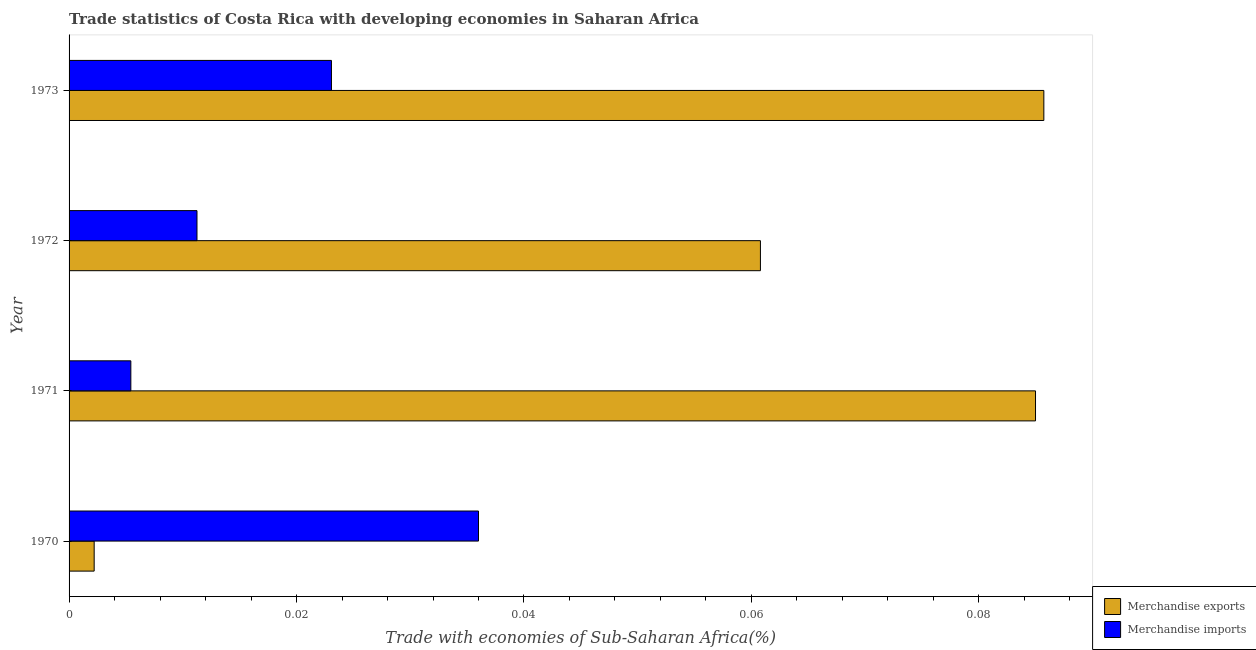How many different coloured bars are there?
Ensure brevity in your answer.  2. How many groups of bars are there?
Keep it short and to the point. 4. How many bars are there on the 2nd tick from the top?
Provide a succinct answer. 2. How many bars are there on the 3rd tick from the bottom?
Offer a terse response. 2. What is the merchandise imports in 1973?
Offer a very short reply. 0.02. Across all years, what is the maximum merchandise exports?
Your answer should be very brief. 0.09. Across all years, what is the minimum merchandise exports?
Offer a terse response. 0. In which year was the merchandise exports maximum?
Offer a terse response. 1973. What is the total merchandise imports in the graph?
Offer a very short reply. 0.08. What is the difference between the merchandise exports in 1970 and that in 1971?
Provide a succinct answer. -0.08. What is the difference between the merchandise imports in 1971 and the merchandise exports in 1972?
Offer a very short reply. -0.06. What is the average merchandise exports per year?
Provide a short and direct response. 0.06. In the year 1973, what is the difference between the merchandise imports and merchandise exports?
Offer a terse response. -0.06. In how many years, is the merchandise imports greater than 0.048 %?
Provide a succinct answer. 0. What is the ratio of the merchandise exports in 1970 to that in 1973?
Provide a short and direct response. 0.03. What is the difference between the highest and the second highest merchandise exports?
Your response must be concise. 0. What is the difference between the highest and the lowest merchandise exports?
Offer a terse response. 0.08. In how many years, is the merchandise exports greater than the average merchandise exports taken over all years?
Keep it short and to the point. 3. Is the sum of the merchandise imports in 1970 and 1972 greater than the maximum merchandise exports across all years?
Offer a very short reply. No. What does the 1st bar from the top in 1971 represents?
Provide a succinct answer. Merchandise imports. What does the 2nd bar from the bottom in 1973 represents?
Keep it short and to the point. Merchandise imports. How many years are there in the graph?
Offer a terse response. 4. What is the difference between two consecutive major ticks on the X-axis?
Your answer should be compact. 0.02. Are the values on the major ticks of X-axis written in scientific E-notation?
Your answer should be compact. No. Does the graph contain any zero values?
Make the answer very short. No. Does the graph contain grids?
Give a very brief answer. No. How are the legend labels stacked?
Provide a short and direct response. Vertical. What is the title of the graph?
Offer a very short reply. Trade statistics of Costa Rica with developing economies in Saharan Africa. Does "% of GNI" appear as one of the legend labels in the graph?
Your answer should be compact. No. What is the label or title of the X-axis?
Your answer should be very brief. Trade with economies of Sub-Saharan Africa(%). What is the Trade with economies of Sub-Saharan Africa(%) in Merchandise exports in 1970?
Your answer should be very brief. 0. What is the Trade with economies of Sub-Saharan Africa(%) in Merchandise imports in 1970?
Your answer should be compact. 0.04. What is the Trade with economies of Sub-Saharan Africa(%) of Merchandise exports in 1971?
Provide a short and direct response. 0.08. What is the Trade with economies of Sub-Saharan Africa(%) in Merchandise imports in 1971?
Offer a terse response. 0.01. What is the Trade with economies of Sub-Saharan Africa(%) in Merchandise exports in 1972?
Make the answer very short. 0.06. What is the Trade with economies of Sub-Saharan Africa(%) in Merchandise imports in 1972?
Give a very brief answer. 0.01. What is the Trade with economies of Sub-Saharan Africa(%) in Merchandise exports in 1973?
Keep it short and to the point. 0.09. What is the Trade with economies of Sub-Saharan Africa(%) of Merchandise imports in 1973?
Make the answer very short. 0.02. Across all years, what is the maximum Trade with economies of Sub-Saharan Africa(%) in Merchandise exports?
Keep it short and to the point. 0.09. Across all years, what is the maximum Trade with economies of Sub-Saharan Africa(%) in Merchandise imports?
Your answer should be compact. 0.04. Across all years, what is the minimum Trade with economies of Sub-Saharan Africa(%) in Merchandise exports?
Keep it short and to the point. 0. Across all years, what is the minimum Trade with economies of Sub-Saharan Africa(%) in Merchandise imports?
Your answer should be compact. 0.01. What is the total Trade with economies of Sub-Saharan Africa(%) in Merchandise exports in the graph?
Keep it short and to the point. 0.23. What is the total Trade with economies of Sub-Saharan Africa(%) in Merchandise imports in the graph?
Offer a terse response. 0.08. What is the difference between the Trade with economies of Sub-Saharan Africa(%) of Merchandise exports in 1970 and that in 1971?
Your response must be concise. -0.08. What is the difference between the Trade with economies of Sub-Saharan Africa(%) in Merchandise imports in 1970 and that in 1971?
Give a very brief answer. 0.03. What is the difference between the Trade with economies of Sub-Saharan Africa(%) in Merchandise exports in 1970 and that in 1972?
Offer a very short reply. -0.06. What is the difference between the Trade with economies of Sub-Saharan Africa(%) of Merchandise imports in 1970 and that in 1972?
Ensure brevity in your answer.  0.02. What is the difference between the Trade with economies of Sub-Saharan Africa(%) in Merchandise exports in 1970 and that in 1973?
Provide a short and direct response. -0.08. What is the difference between the Trade with economies of Sub-Saharan Africa(%) of Merchandise imports in 1970 and that in 1973?
Provide a short and direct response. 0.01. What is the difference between the Trade with economies of Sub-Saharan Africa(%) in Merchandise exports in 1971 and that in 1972?
Give a very brief answer. 0.02. What is the difference between the Trade with economies of Sub-Saharan Africa(%) in Merchandise imports in 1971 and that in 1972?
Give a very brief answer. -0.01. What is the difference between the Trade with economies of Sub-Saharan Africa(%) in Merchandise exports in 1971 and that in 1973?
Offer a terse response. -0. What is the difference between the Trade with economies of Sub-Saharan Africa(%) of Merchandise imports in 1971 and that in 1973?
Provide a short and direct response. -0.02. What is the difference between the Trade with economies of Sub-Saharan Africa(%) in Merchandise exports in 1972 and that in 1973?
Offer a terse response. -0.02. What is the difference between the Trade with economies of Sub-Saharan Africa(%) of Merchandise imports in 1972 and that in 1973?
Your answer should be compact. -0.01. What is the difference between the Trade with economies of Sub-Saharan Africa(%) in Merchandise exports in 1970 and the Trade with economies of Sub-Saharan Africa(%) in Merchandise imports in 1971?
Offer a very short reply. -0. What is the difference between the Trade with economies of Sub-Saharan Africa(%) in Merchandise exports in 1970 and the Trade with economies of Sub-Saharan Africa(%) in Merchandise imports in 1972?
Provide a short and direct response. -0.01. What is the difference between the Trade with economies of Sub-Saharan Africa(%) of Merchandise exports in 1970 and the Trade with economies of Sub-Saharan Africa(%) of Merchandise imports in 1973?
Provide a short and direct response. -0.02. What is the difference between the Trade with economies of Sub-Saharan Africa(%) of Merchandise exports in 1971 and the Trade with economies of Sub-Saharan Africa(%) of Merchandise imports in 1972?
Offer a terse response. 0.07. What is the difference between the Trade with economies of Sub-Saharan Africa(%) in Merchandise exports in 1971 and the Trade with economies of Sub-Saharan Africa(%) in Merchandise imports in 1973?
Give a very brief answer. 0.06. What is the difference between the Trade with economies of Sub-Saharan Africa(%) in Merchandise exports in 1972 and the Trade with economies of Sub-Saharan Africa(%) in Merchandise imports in 1973?
Offer a very short reply. 0.04. What is the average Trade with economies of Sub-Saharan Africa(%) in Merchandise exports per year?
Your response must be concise. 0.06. What is the average Trade with economies of Sub-Saharan Africa(%) in Merchandise imports per year?
Make the answer very short. 0.02. In the year 1970, what is the difference between the Trade with economies of Sub-Saharan Africa(%) of Merchandise exports and Trade with economies of Sub-Saharan Africa(%) of Merchandise imports?
Make the answer very short. -0.03. In the year 1971, what is the difference between the Trade with economies of Sub-Saharan Africa(%) of Merchandise exports and Trade with economies of Sub-Saharan Africa(%) of Merchandise imports?
Ensure brevity in your answer.  0.08. In the year 1972, what is the difference between the Trade with economies of Sub-Saharan Africa(%) of Merchandise exports and Trade with economies of Sub-Saharan Africa(%) of Merchandise imports?
Ensure brevity in your answer.  0.05. In the year 1973, what is the difference between the Trade with economies of Sub-Saharan Africa(%) of Merchandise exports and Trade with economies of Sub-Saharan Africa(%) of Merchandise imports?
Give a very brief answer. 0.06. What is the ratio of the Trade with economies of Sub-Saharan Africa(%) of Merchandise exports in 1970 to that in 1971?
Offer a very short reply. 0.03. What is the ratio of the Trade with economies of Sub-Saharan Africa(%) of Merchandise imports in 1970 to that in 1971?
Keep it short and to the point. 6.63. What is the ratio of the Trade with economies of Sub-Saharan Africa(%) in Merchandise exports in 1970 to that in 1972?
Offer a very short reply. 0.04. What is the ratio of the Trade with economies of Sub-Saharan Africa(%) in Merchandise imports in 1970 to that in 1972?
Keep it short and to the point. 3.2. What is the ratio of the Trade with economies of Sub-Saharan Africa(%) in Merchandise exports in 1970 to that in 1973?
Provide a succinct answer. 0.03. What is the ratio of the Trade with economies of Sub-Saharan Africa(%) of Merchandise imports in 1970 to that in 1973?
Your response must be concise. 1.56. What is the ratio of the Trade with economies of Sub-Saharan Africa(%) in Merchandise exports in 1971 to that in 1972?
Your answer should be very brief. 1.4. What is the ratio of the Trade with economies of Sub-Saharan Africa(%) in Merchandise imports in 1971 to that in 1972?
Your response must be concise. 0.48. What is the ratio of the Trade with economies of Sub-Saharan Africa(%) of Merchandise exports in 1971 to that in 1973?
Keep it short and to the point. 0.99. What is the ratio of the Trade with economies of Sub-Saharan Africa(%) of Merchandise imports in 1971 to that in 1973?
Provide a succinct answer. 0.24. What is the ratio of the Trade with economies of Sub-Saharan Africa(%) of Merchandise exports in 1972 to that in 1973?
Ensure brevity in your answer.  0.71. What is the ratio of the Trade with economies of Sub-Saharan Africa(%) of Merchandise imports in 1972 to that in 1973?
Provide a short and direct response. 0.49. What is the difference between the highest and the second highest Trade with economies of Sub-Saharan Africa(%) in Merchandise exports?
Give a very brief answer. 0. What is the difference between the highest and the second highest Trade with economies of Sub-Saharan Africa(%) of Merchandise imports?
Your response must be concise. 0.01. What is the difference between the highest and the lowest Trade with economies of Sub-Saharan Africa(%) in Merchandise exports?
Give a very brief answer. 0.08. What is the difference between the highest and the lowest Trade with economies of Sub-Saharan Africa(%) of Merchandise imports?
Offer a terse response. 0.03. 